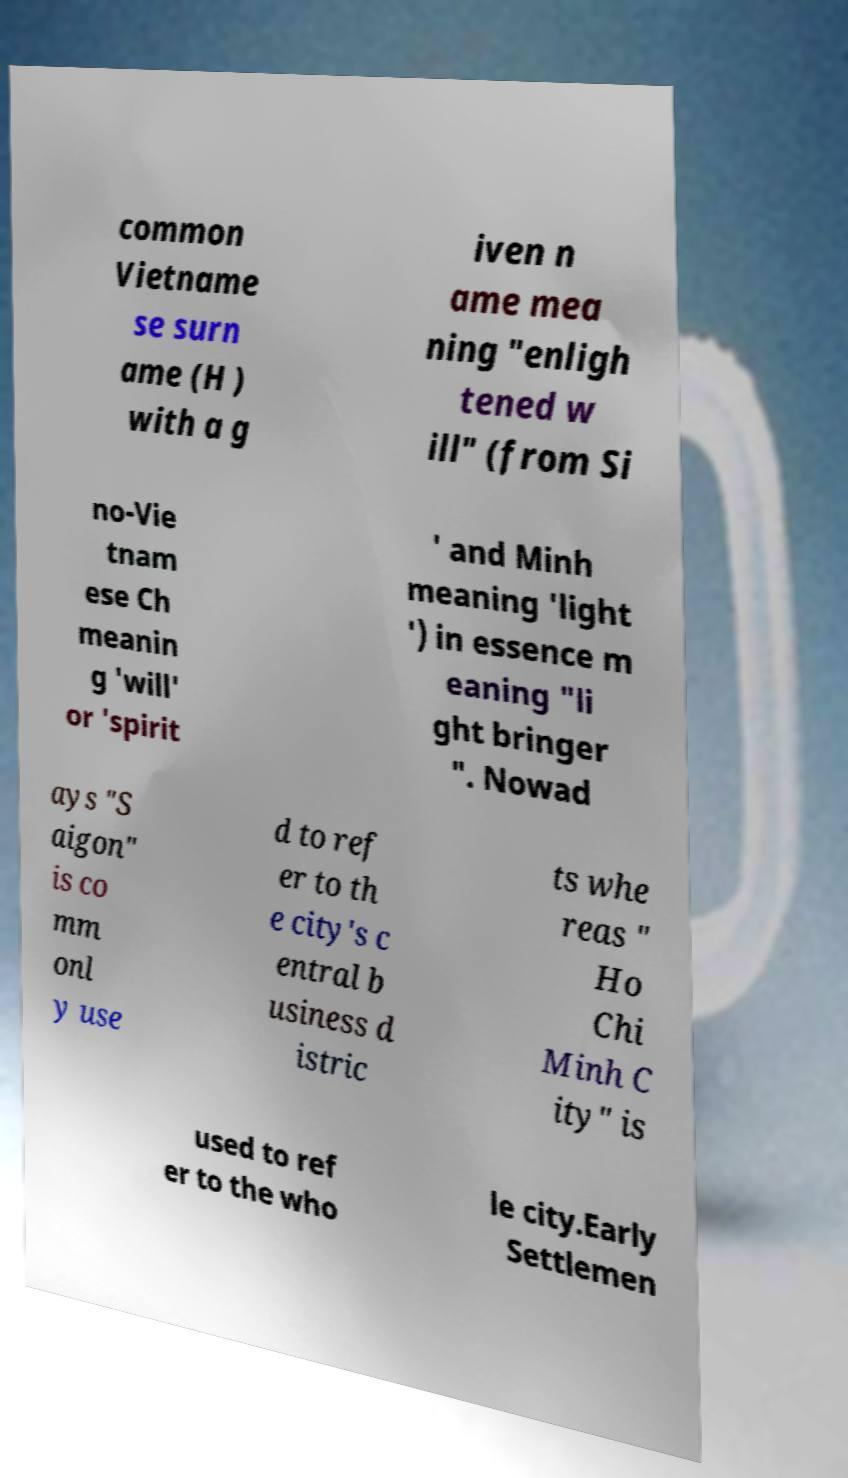For documentation purposes, I need the text within this image transcribed. Could you provide that? common Vietname se surn ame (H ) with a g iven n ame mea ning "enligh tened w ill" (from Si no-Vie tnam ese Ch meanin g 'will' or 'spirit ' and Minh meaning 'light ') in essence m eaning "li ght bringer ". Nowad ays "S aigon" is co mm onl y use d to ref er to th e city's c entral b usiness d istric ts whe reas " Ho Chi Minh C ity" is used to ref er to the who le city.Early Settlemen 